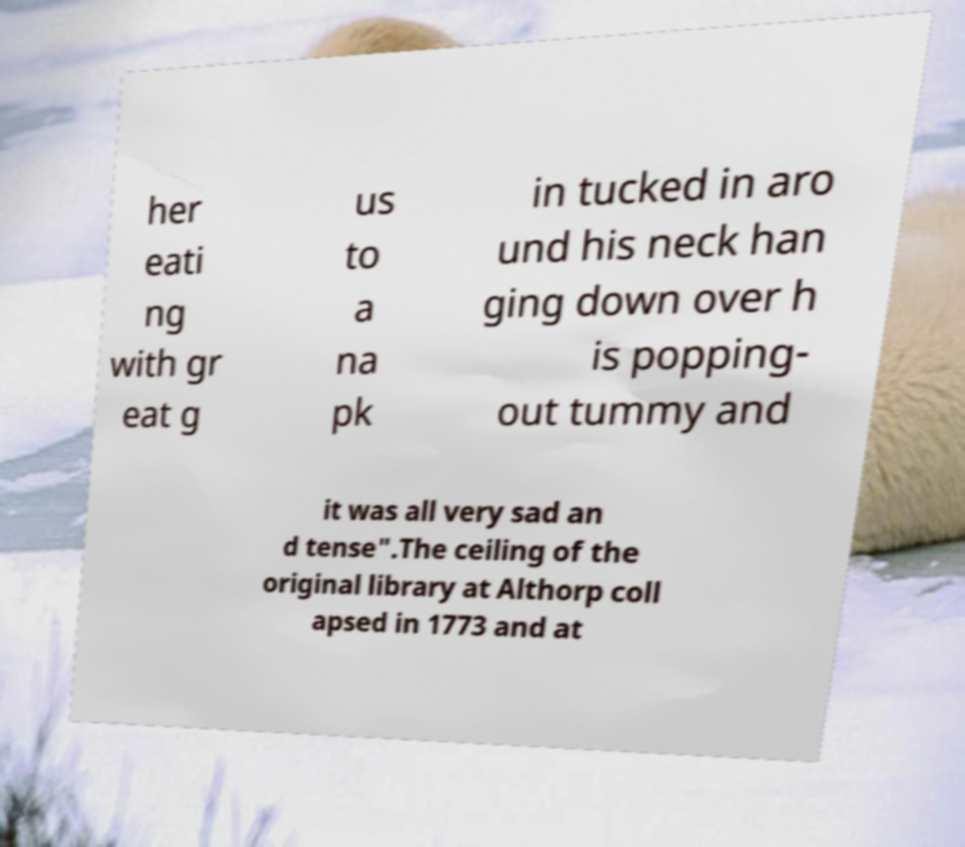Can you accurately transcribe the text from the provided image for me? her eati ng with gr eat g us to a na pk in tucked in aro und his neck han ging down over h is popping- out tummy and it was all very sad an d tense".The ceiling of the original library at Althorp coll apsed in 1773 and at 